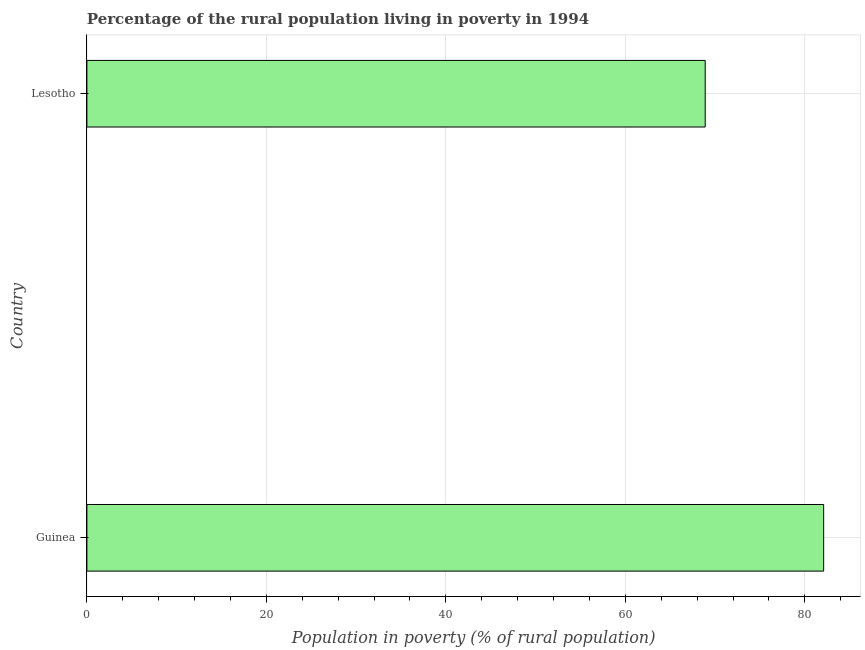What is the title of the graph?
Your answer should be compact. Percentage of the rural population living in poverty in 1994. What is the label or title of the X-axis?
Provide a short and direct response. Population in poverty (% of rural population). What is the percentage of rural population living below poverty line in Guinea?
Offer a terse response. 82.1. Across all countries, what is the maximum percentage of rural population living below poverty line?
Your answer should be compact. 82.1. Across all countries, what is the minimum percentage of rural population living below poverty line?
Ensure brevity in your answer.  68.9. In which country was the percentage of rural population living below poverty line maximum?
Your answer should be compact. Guinea. In which country was the percentage of rural population living below poverty line minimum?
Keep it short and to the point. Lesotho. What is the sum of the percentage of rural population living below poverty line?
Provide a succinct answer. 151. What is the average percentage of rural population living below poverty line per country?
Keep it short and to the point. 75.5. What is the median percentage of rural population living below poverty line?
Ensure brevity in your answer.  75.5. In how many countries, is the percentage of rural population living below poverty line greater than 8 %?
Keep it short and to the point. 2. What is the ratio of the percentage of rural population living below poverty line in Guinea to that in Lesotho?
Provide a short and direct response. 1.19. In how many countries, is the percentage of rural population living below poverty line greater than the average percentage of rural population living below poverty line taken over all countries?
Offer a terse response. 1. What is the Population in poverty (% of rural population) of Guinea?
Give a very brief answer. 82.1. What is the Population in poverty (% of rural population) in Lesotho?
Ensure brevity in your answer.  68.9. What is the ratio of the Population in poverty (% of rural population) in Guinea to that in Lesotho?
Keep it short and to the point. 1.19. 